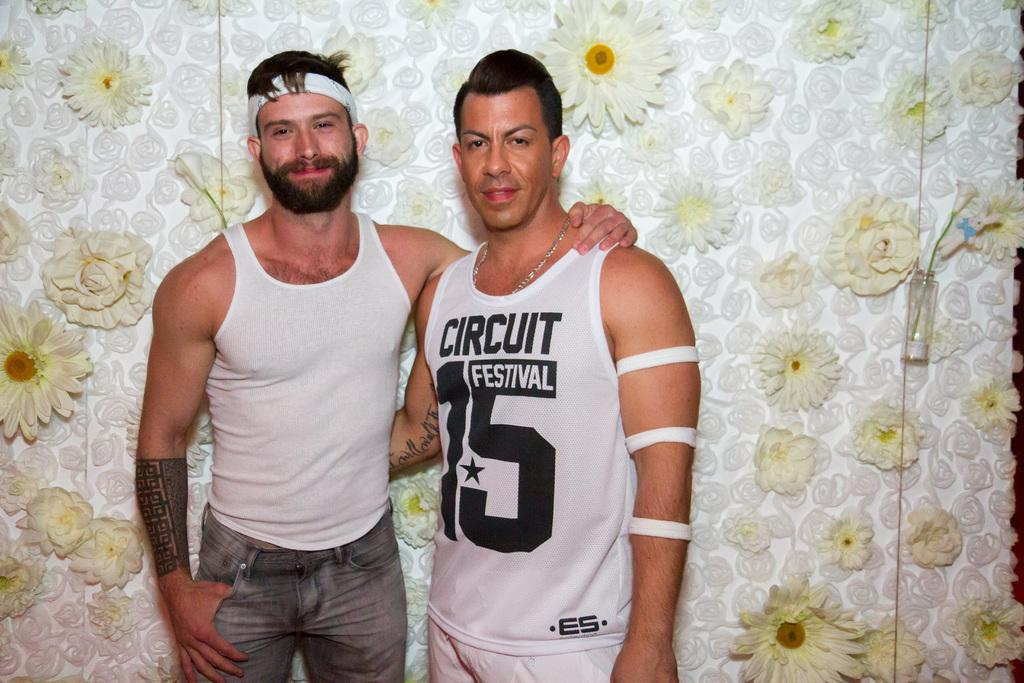Provide a one-sentence caption for the provided image. Circuit Festival 15 is printed on the tank top of this gentleman. 